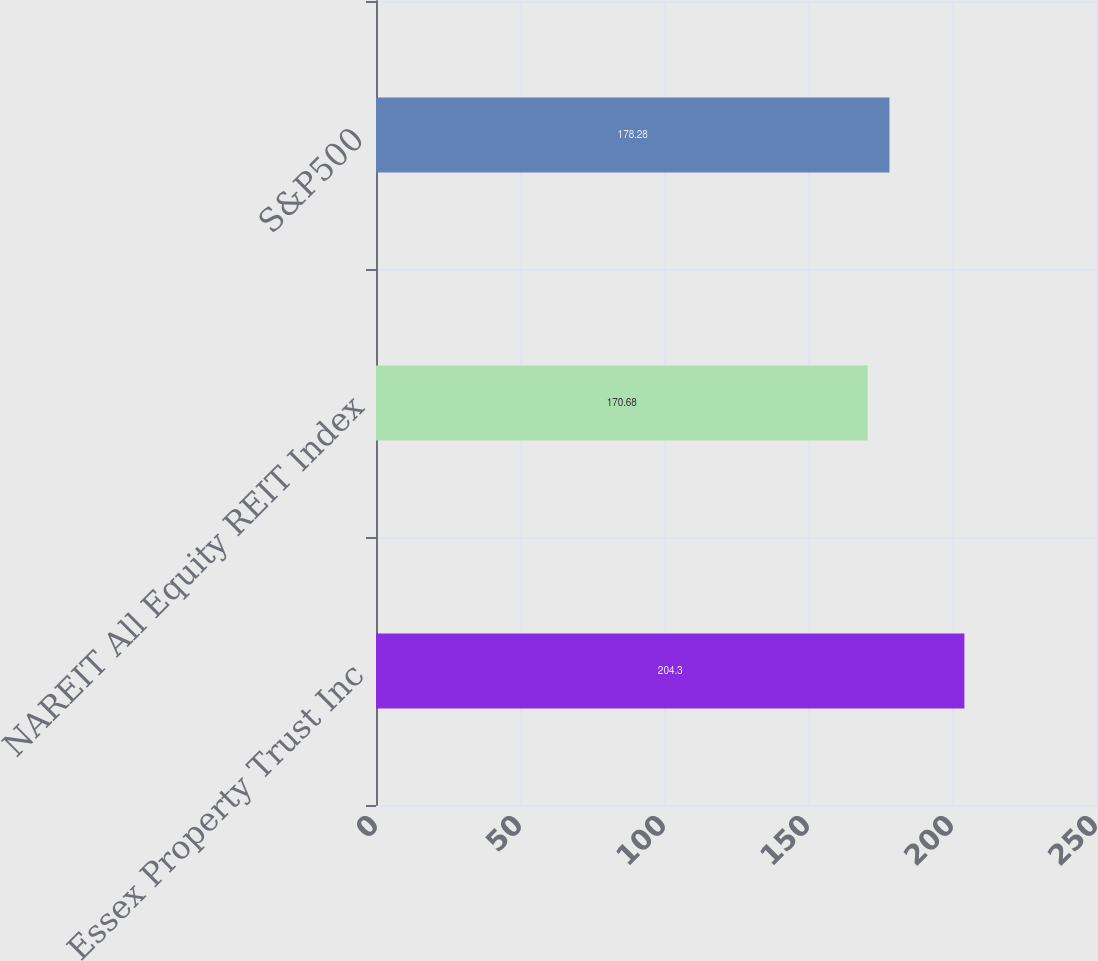<chart> <loc_0><loc_0><loc_500><loc_500><bar_chart><fcel>Essex Property Trust Inc<fcel>NAREIT All Equity REIT Index<fcel>S&P500<nl><fcel>204.3<fcel>170.68<fcel>178.28<nl></chart> 